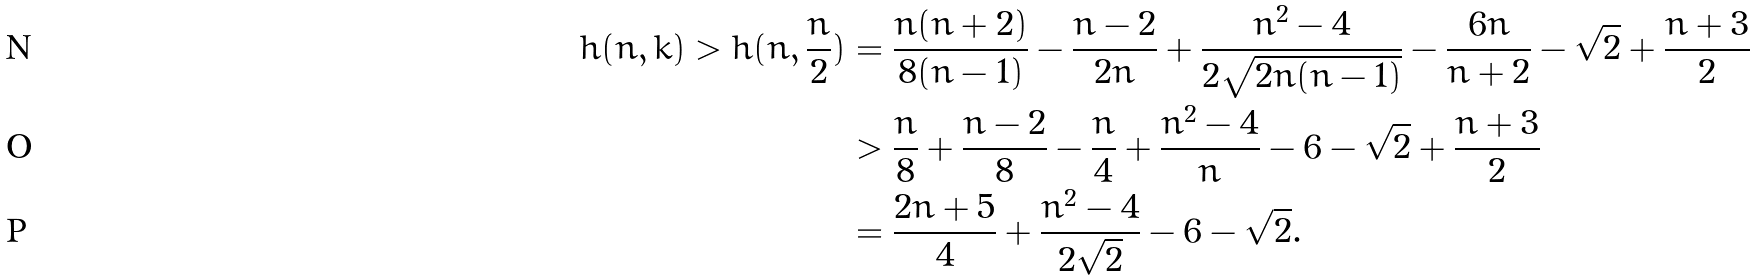<formula> <loc_0><loc_0><loc_500><loc_500>h ( n , k ) > h ( n , \frac { n } { 2 } ) & = \frac { n ( n + 2 ) } { 8 ( n - 1 ) } - \frac { n - 2 } { 2 n } + \frac { n ^ { 2 } - 4 } { 2 \sqrt { 2 n ( n - 1 ) } } - \frac { 6 n } { n + 2 } - \sqrt { 2 } + \frac { n + 3 } 2 \\ & > \frac { n } { 8 } + \frac { n - 2 } 8 - \frac { n } { 4 } + \frac { n ^ { 2 } - 4 } n - 6 - \sqrt { 2 } + \frac { n + 3 } 2 \\ & = \frac { 2 n + 5 } 4 + \frac { n ^ { 2 } - 4 } { 2 \sqrt { 2 } } - 6 - \sqrt { 2 } .</formula> 